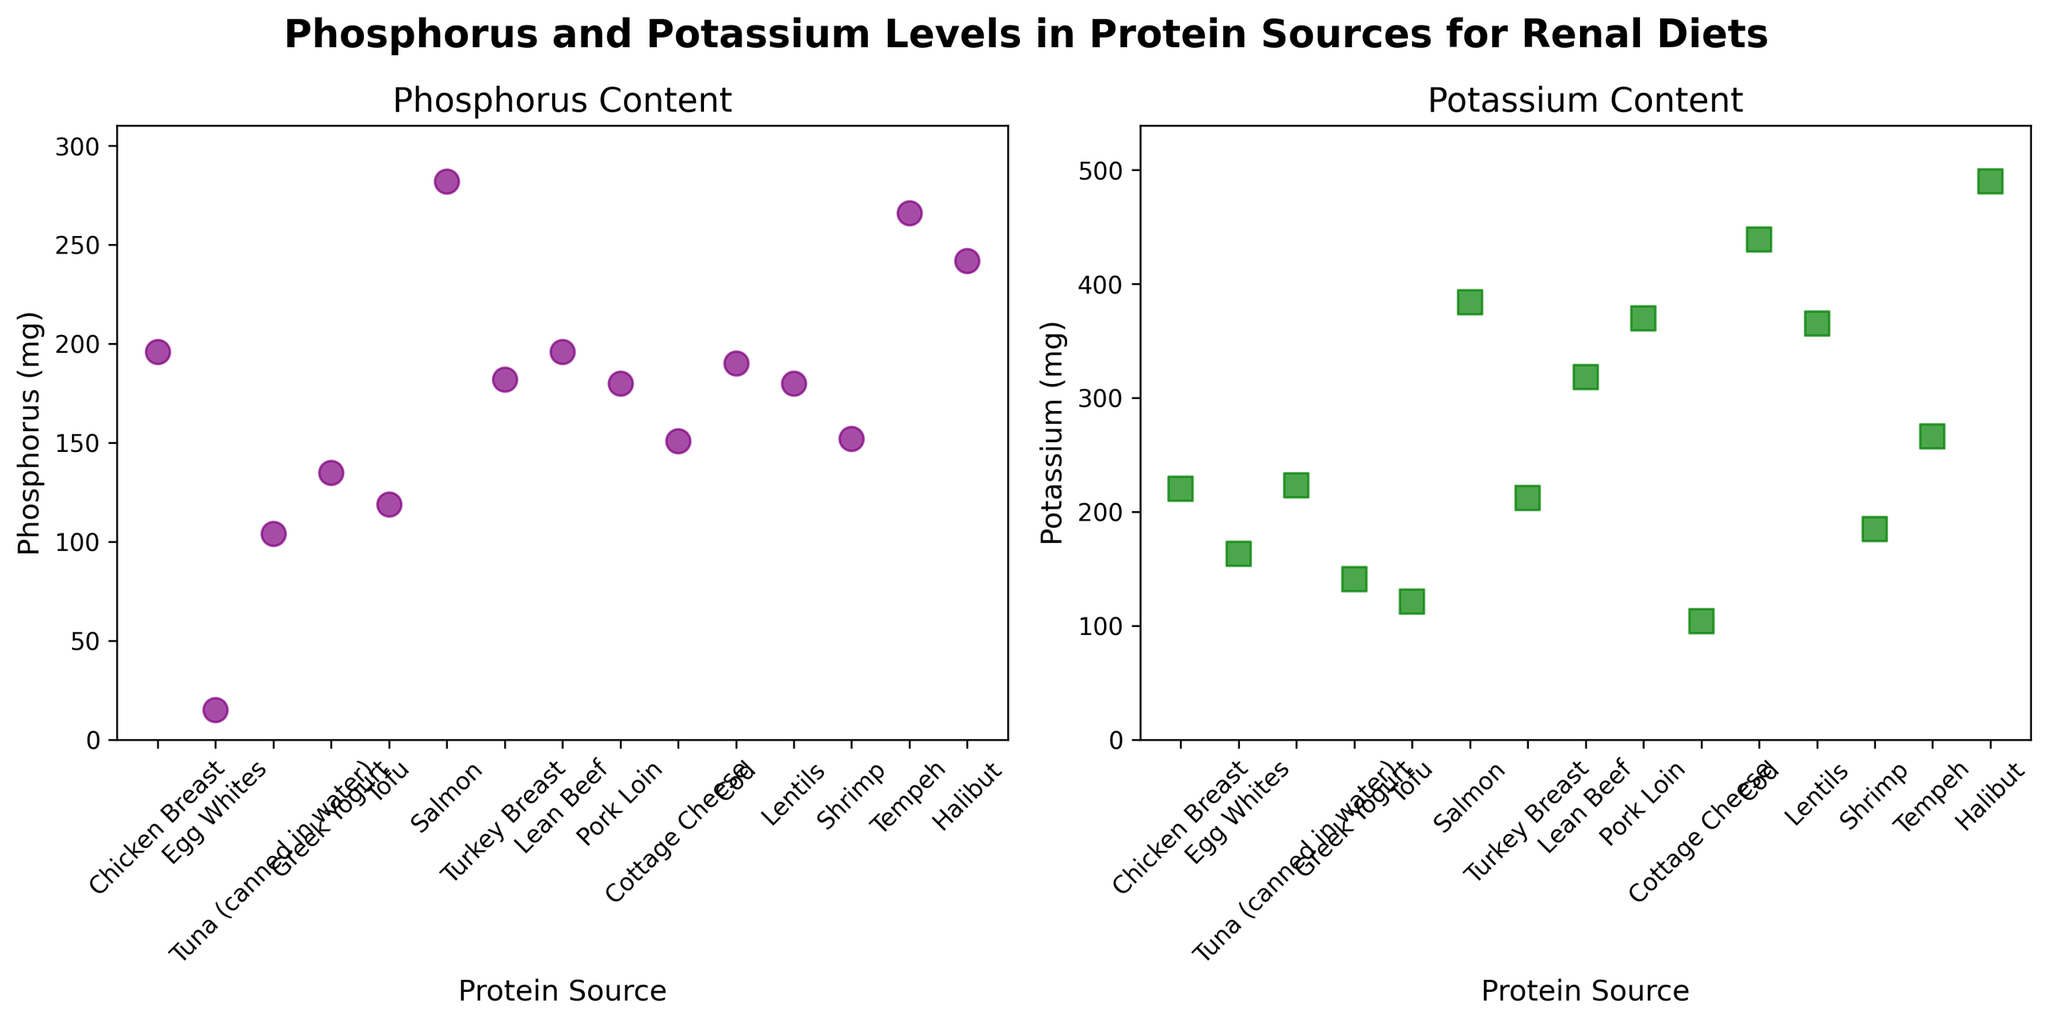What is the title of the figure? The title of the figure is usually displayed at the top center. In this case, it clearly mentions "Phosphorus and Potassium Levels in Protein Sources for Renal Diets".
Answer: Phosphorus and Potassium Levels in Protein Sources for Renal Diets Which protein source has the highest phosphorus content? To find this, identify the data point on the Phosphorus plot with the highest y-value. Here, that point is for Salmon with a value of 282 mg.
Answer: Salmon What is the range of potassium content across all protein sources? The range is calculated by subtracting the smallest potassium value from the largest potassium value. The smallest is for Cottage Cheese (104 mg) and the largest for Halibut (490 mg). So, 490 - 104 = 386 mg.
Answer: 386 mg How many protein sources have phosphorus content greater than 200 mg? Count the number of data points in the Phosphorus plot where the phosphorus value exceeds 200 mg. The protein sources meeting this criterion are Salmon and Halibut (2 sources).
Answer: 2 Which protein source has the smallest difference between phosphorus and potassium content? To determine this, calculate the absolute difference between phosphorus and potassium content for each protein source. The smallest difference is for Tempeh where both values are 266 mg, making the difference 0 mg.
Answer: Tempeh Is the potassium content generally higher or lower than the phosphorus content for most protein sources? Compare the data points on both plots. For most protein sources, the potassium levels are generally higher than phosphorus levels, e.g., Cod has a potassium level of 439 mg and phosphorus level of 190 mg.
Answer: Higher Which protein sources have both phosphorus and potassium content below 200 mg? Identify the data points on both plots that fall below the 200 mg mark for both nutrients: Egg Whites and Tofu.
Answer: Egg Whites, Tofu What is the average potassium content of the protein sources listed? Sum the potassium content of all protein sources and divide by the number of sources. (220 + 163 + 223 + 141 + 121 + 384 + 212 + 318 + 370 + 104 + 439 + 365 + 185 + 266 + 490) / 15 ≈ 263.
Answer: 263 mg Which protein sources have higher potassium content than phosphorus content? Compare each protein source's potassium and phosphorus content. The sources where potassium is higher are Chicken Breast, Tuna, Lean Beef, Pork Loin, Cod, Lentils, Halibut.
Answer: Chicken Breast, Tuna, Lean Beef, Pork Loin, Cod, Lentils, Halibut How does the potassium content of Greek Yogurt compare to that of Shrimp? Look at the potassium content values for both: Greek Yogurt has 141 mg and Shrimp has 185 mg. Shrimp has higher potassium.
Answer: Shrimp is higher 